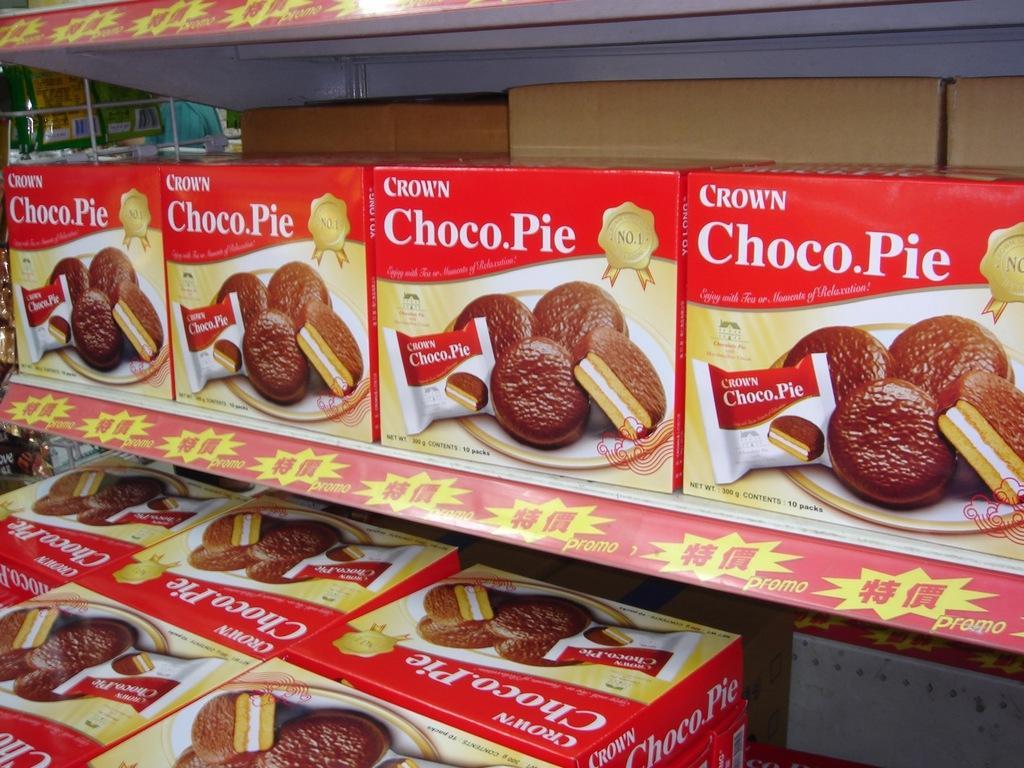Can you describe this image briefly? In this picture we can see carton boxes in the rack. On the cotton boxes we can see biscuits on a plate. On the top left corner we can see some objects near to the wall. 